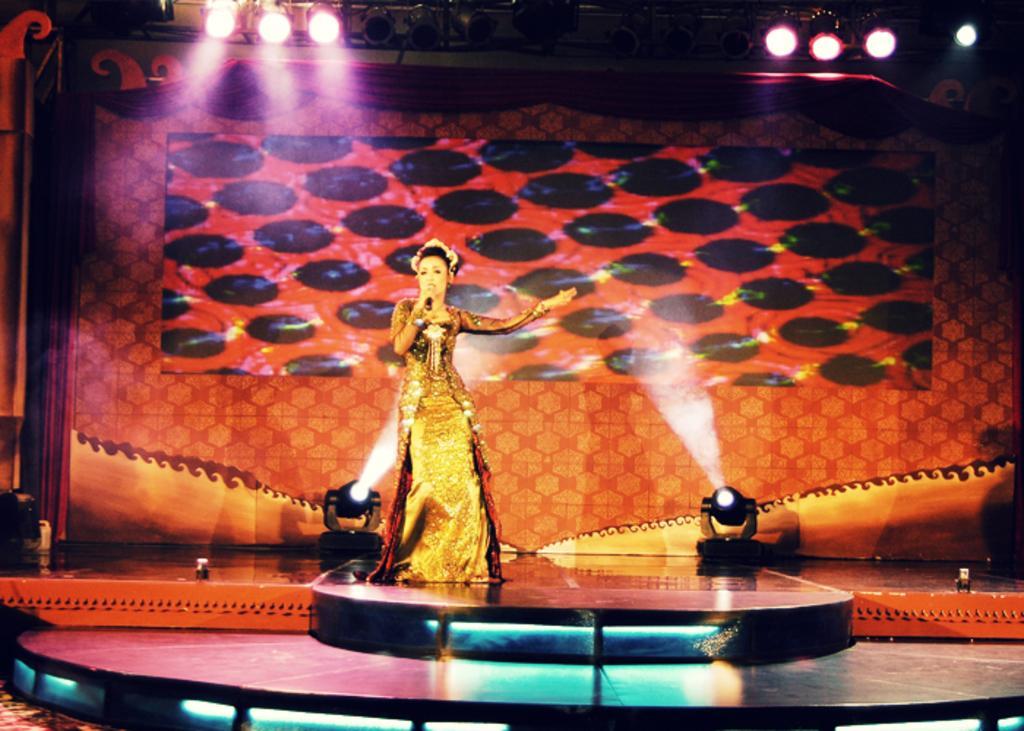Can you describe this image briefly? In this picture there is a woman standing on the stage and she is holding the microphone. At the top there are lights. At the back there is a screen and there is a curtain. At the bottom there are lights. 